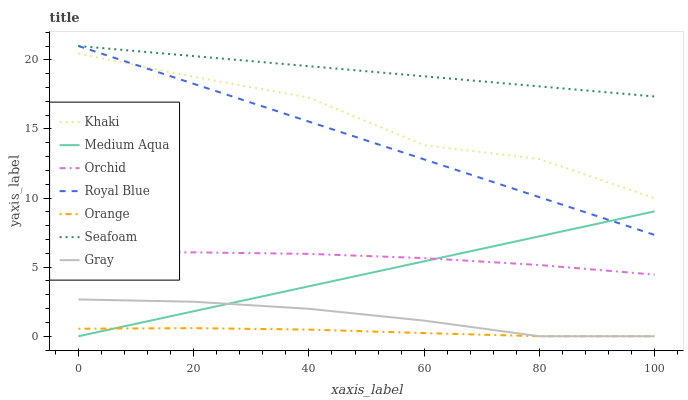Does Orange have the minimum area under the curve?
Answer yes or no. Yes. Does Seafoam have the maximum area under the curve?
Answer yes or no. Yes. Does Khaki have the minimum area under the curve?
Answer yes or no. No. Does Khaki have the maximum area under the curve?
Answer yes or no. No. Is Seafoam the smoothest?
Answer yes or no. Yes. Is Khaki the roughest?
Answer yes or no. Yes. Is Khaki the smoothest?
Answer yes or no. No. Is Seafoam the roughest?
Answer yes or no. No. Does Gray have the lowest value?
Answer yes or no. Yes. Does Khaki have the lowest value?
Answer yes or no. No. Does Royal Blue have the highest value?
Answer yes or no. Yes. Does Khaki have the highest value?
Answer yes or no. No. Is Orchid less than Khaki?
Answer yes or no. Yes. Is Seafoam greater than Gray?
Answer yes or no. Yes. Does Medium Aqua intersect Orange?
Answer yes or no. Yes. Is Medium Aqua less than Orange?
Answer yes or no. No. Is Medium Aqua greater than Orange?
Answer yes or no. No. Does Orchid intersect Khaki?
Answer yes or no. No. 